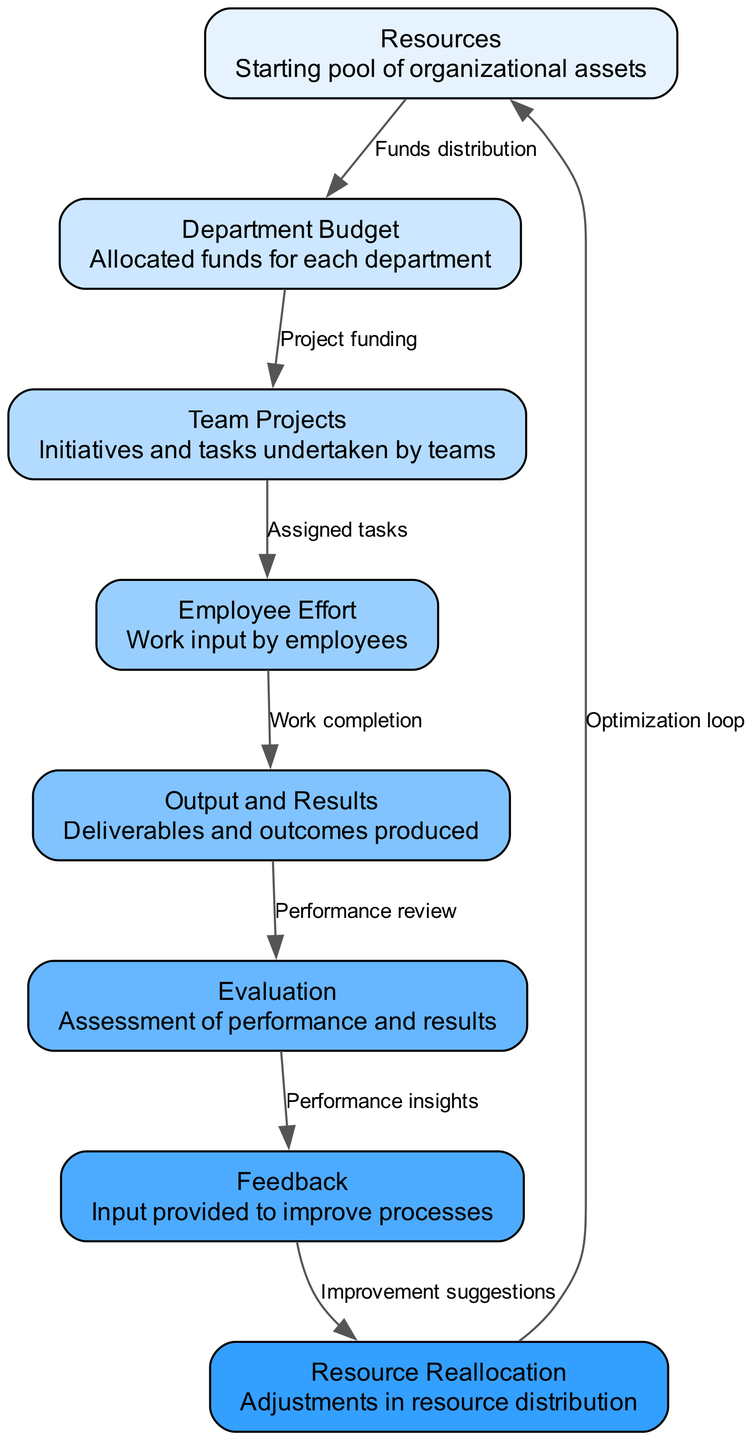What is the starting pool of organizational assets? The first node in the diagram is "Resources," which is defined as the starting pool of organizational assets. This node is the initial point in the nutrient cycle and indicates what the organization has available.
Answer: Resources How many nodes are in the diagram? By counting all the unique nodes listed in the elements, we find that there are 8 nodes: Resources, Department Budget, Team Projects, Employee Effort, Output and Results, Evaluation, Feedback, Resource Reallocation.
Answer: 8 Which node directly receives feedback in the cycle? The "Feedback" node is the one that provides input for improving processes. Looking at the edges, we see that it connects to "Resource Reallocation," meaning it does not directly receive feedback but supplies it. To clarify, "Feedback" is not a receiver but a provider in the process.
Answer: Resource Reallocation What connects Employee Effort to Output and Results? The edge labeled "Employee Effort to Output and Results" represents the relationship between these two nodes, stating that the work done by employees leads to the creation of deliverables and outcomes, hence forming a direct connection.
Answer: Work completion After evaluation, what is the next step in the cycle? Once the Evaluation node assesses performance and results, it connects to the Feedback node, which suggests that feedback is the subsequent process to consider after evaluation. This highlights the iterative nature of the cycle, where results lead to insights.
Answer: Feedback How does the resource flow back to resources in the cycle? The edge from "Resource Reallocation" to "Resources" signifies the feedback loop in the cycle. This means that after assessing and reallocating resources based on feedback, the adjustments are made back to the original pool of resources.
Answer: Optimization loop How many edges are in the diagram? By reviewing each connection between nodes, we find a total of 7 edges that indicate separate relationships, showing the flow of resources through different stages in the corporate nutrient cycle.
Answer: 7 What is the relationship between the Department Budget and Team Projects? The edge labeled "Department Budget to Team Projects" indicates that there is a direct link where funds allocated to departments are used to finance various team projects within those departments, emphasizing the financial framework governing project initiation.
Answer: Project funding 